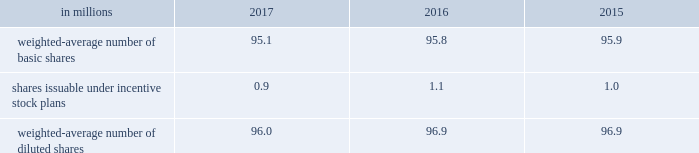Note 18 2013 earnings per share ( eps ) basic eps is calculated by dividing net earnings attributable to allegion plc by the weighted-average number of ordinary shares outstanding for the applicable period .
Diluted eps is calculated after adjusting the denominator of the basic eps calculation for the effect of all potentially dilutive ordinary shares , which in the company 2019s case , includes shares issuable under share-based compensation plans .
The table summarizes the weighted-average number of ordinary shares outstanding for basic and diluted earnings per share calculations. .
At december 31 , 2017 , 0.1 million stock options were excluded from the computation of weighted average diluted shares outstanding because the effect of including these shares would have been anti-dilutive .
Note 19 2013 commitments and contingencies the company is involved in various litigations , claims and administrative proceedings , including those related to environmental and product warranty matters .
Amounts recorded for identified contingent liabilities are estimates , which are reviewed periodically and adjusted to reflect additional information when it becomes available .
Subject to the uncertainties inherent in estimating future costs for contingent liabilities , except as expressly set forth in this note , management believes that any liability which may result from these legal matters would not have a material adverse effect on the financial condition , results of operations , liquidity or cash flows of the company .
Environmental matters the company is dedicated to an environmental program to reduce the utilization and generation of hazardous materials during the manufacturing process and to remediate identified environmental concerns .
As to the latter , the company is currently engaged in site investigations and remediation activities to address environmental cleanup from past operations at current and former production facilities .
The company regularly evaluates its remediation programs and considers alternative remediation methods that are in addition to , or in replacement of , those currently utilized by the company based upon enhanced technology and regulatory changes .
Changes to the company's remediation programs may result in increased expenses and increased environmental reserves .
The company is sometimes a party to environmental lawsuits and claims and has received notices of potential violations of environmental laws and regulations from the u.s .
Environmental protection agency and similar state authorities .
It has also been identified as a potentially responsible party ( "prp" ) for cleanup costs associated with off-site waste disposal at federal superfund and state remediation sites .
For all such sites , there are other prps and , in most instances , the company 2019s involvement is minimal .
In estimating its liability , the company has assumed it will not bear the entire cost of remediation of any site to the exclusion of other prps who may be jointly and severally liable .
The ability of other prps to participate has been taken into account , based on our understanding of the parties 2019 financial condition and probable contributions on a per site basis .
Additional lawsuits and claims involving environmental matters are likely to arise from time to time in the future .
The company incurred $ 3.2 million , $ 23.3 million , and $ 4.4 million of expenses during the years ended december 31 , 2017 , 2016 and 2015 , respectively , for environmental remediation at sites presently or formerly owned or leased by the company .
In the fourth-quarter of 2016 , with the collaboration and approval of state regulators , the company launched a proactive , alternative approach to remediate two sites in the united states .
This approach will allow the company to more aggressively address environmental conditions at these sites and reduce the impact of potential changes in regulatory requirements .
As a result , the company recorded a $ 15 million charge for environmental remediation in the fourth quarter of 2016 .
Environmental remediation costs are recorded in costs of goods sold within the consolidated statements of comprehensive income .
As of december 31 , 2017 and 2016 , the company has recorded reserves for environmental matters of $ 28.9 million and $ 30.6 million .
The total reserve at december 31 , 2017 and 2016 included $ 8.9 million and $ 9.6 million related to remediation of sites previously disposed by the company .
Environmental reserves are classified as accrued expenses and other current liabilities or other noncurrent liabilities based on their expected term .
The company's total current environmental reserve at december 31 , 2017 and 2016 was $ 12.6 million and $ 6.1 million and the remainder is classified as noncurrent .
Given the evolving nature of environmental laws , regulations and technology , the ultimate cost of future compliance is uncertain. .
What is the percentual decrease observed in the reserves for environmental matters during 2016 and 2017? 
Rationale: it is the final value of reserves ( $ 28.9 ) minus the initial one ( $ 30.6 ) , then divided by the initial and turned into a percentage to represent the decrease .
Computations: (((28.9 - 30.6) / 30.6) * 100)
Answer: -5.55556. 